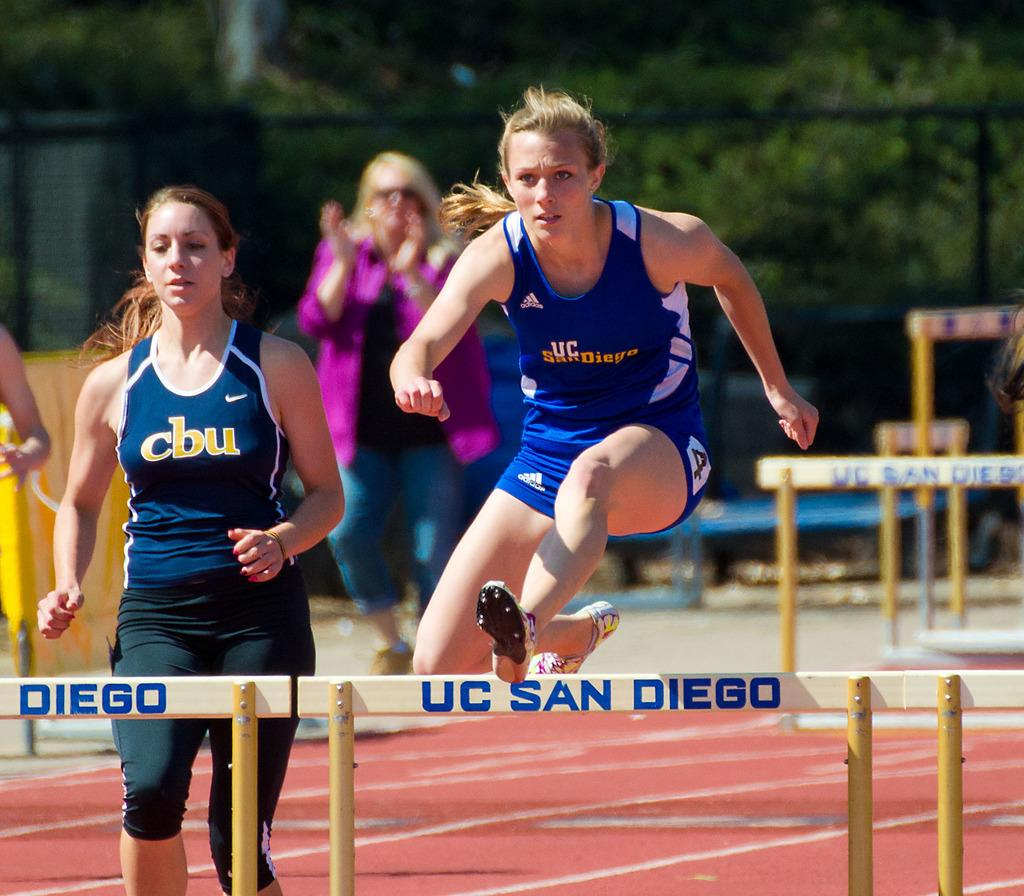<image>
Render a clear and concise summary of the photo. A runner jumping a hurdle from UC SAN DIEGO. 